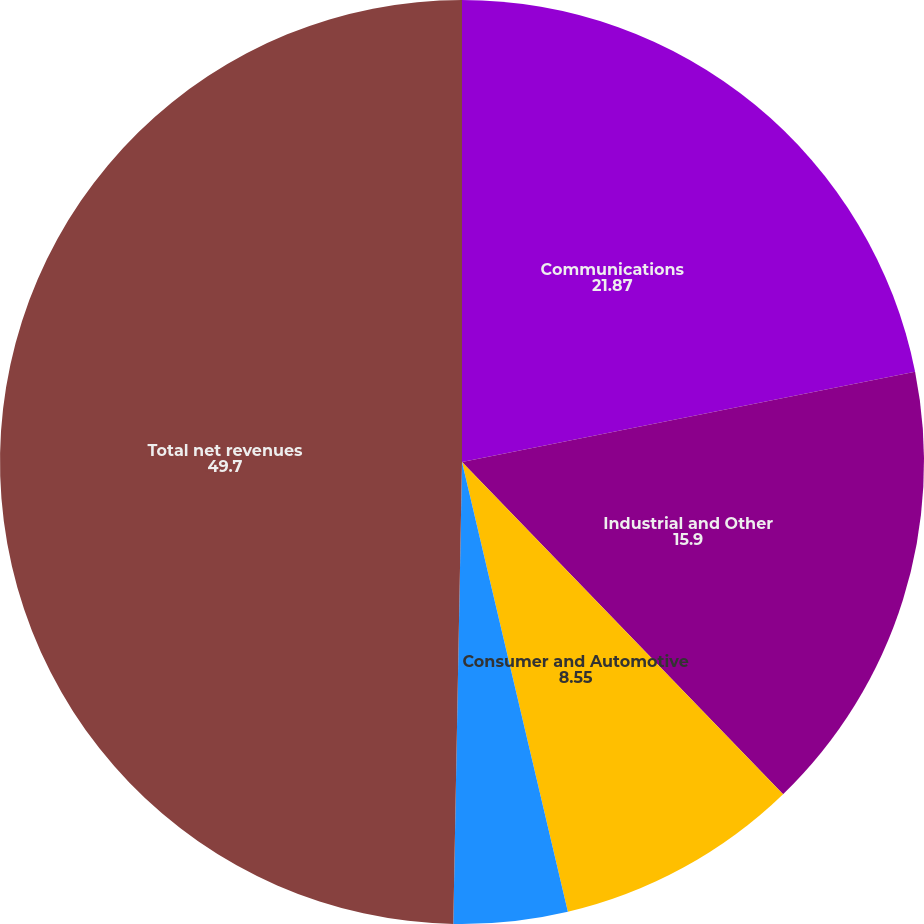Convert chart to OTSL. <chart><loc_0><loc_0><loc_500><loc_500><pie_chart><fcel>Communications<fcel>Industrial and Other<fcel>Consumer and Automotive<fcel>Data Processing<fcel>Total net revenues<nl><fcel>21.87%<fcel>15.9%<fcel>8.55%<fcel>3.98%<fcel>49.7%<nl></chart> 